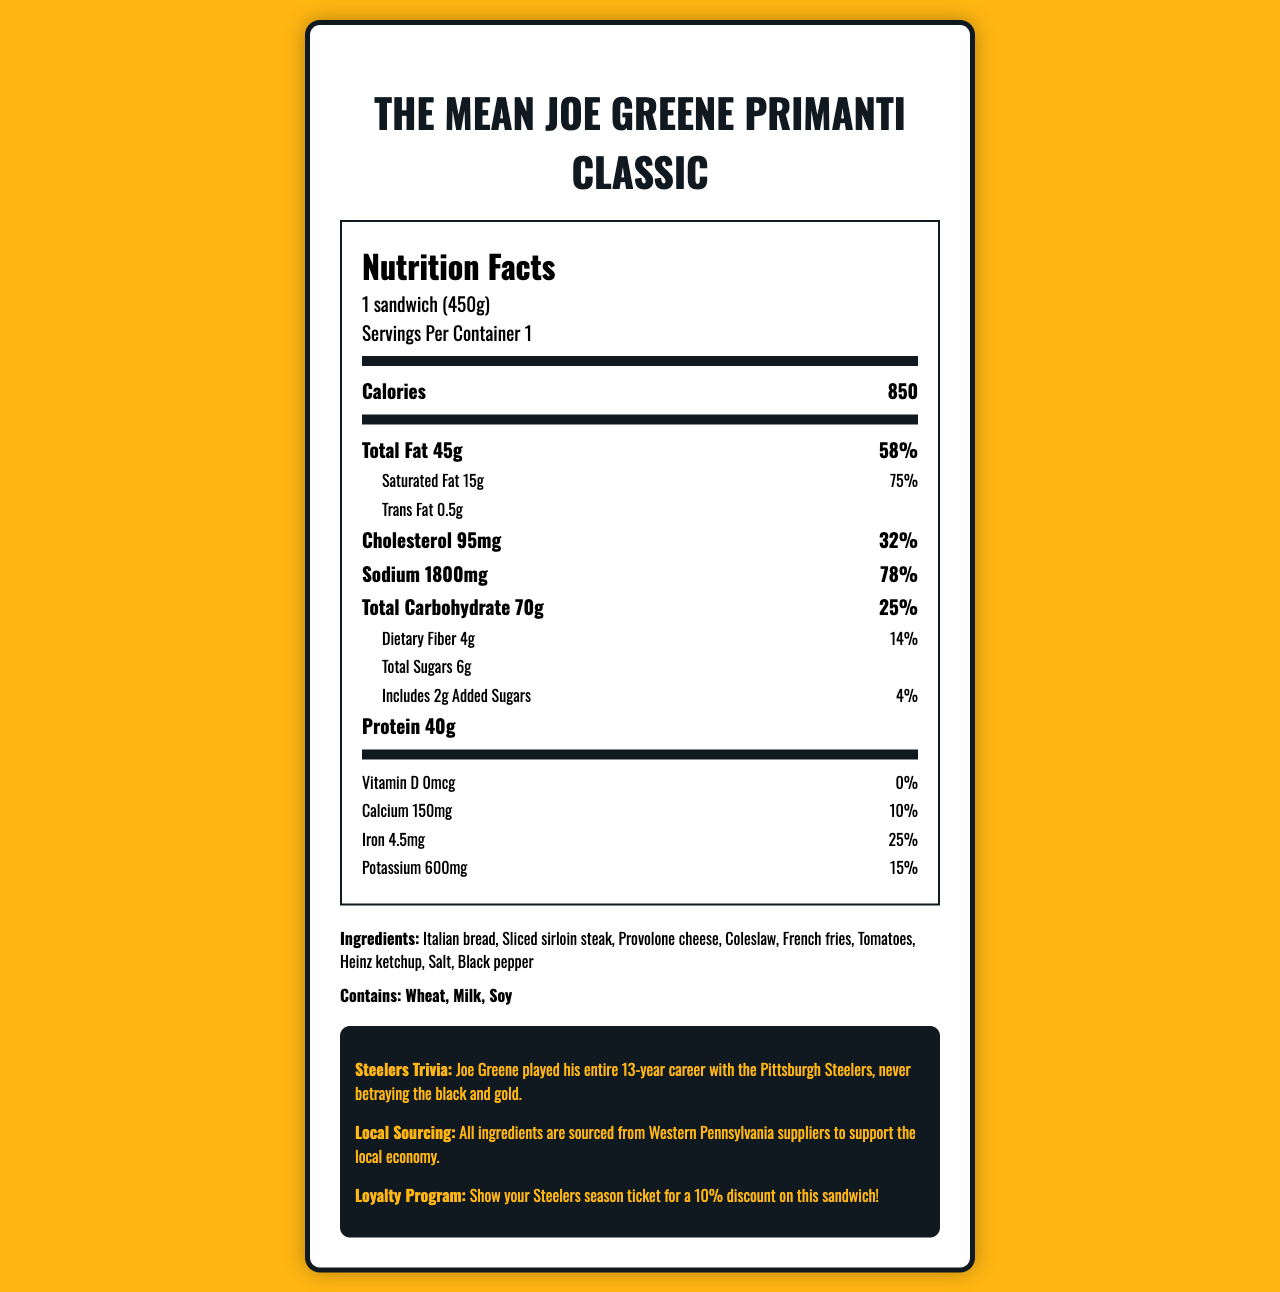what is the serving size of "The Mean Joe Greene Primanti Classic"? The serving size is stated as "1 sandwich (450g)" at the top of the nutrition label.
Answer: 1 sandwich (450g) how many calories does the sandwich contain? The calorie count is listed as "Calories 850" in the document.
Answer: 850 how much total fat is in the sandwich? The total fat content is listed in the section "Total Fat 45g" followed by its daily value percentage.
Answer: 45g how much protein does the sandwich provide? The protein content is stated as "Protein 40g" under the nutrition facts.
Answer: 40g what is the sodium content in the sandwich? The sodium content is given as "Sodium 1800mg" along with its daily value percentage.
Answer: 1800mg what is the daily value percentage of saturated fat in the sandwich? The daily value percentage for saturated fat is listed as 75% directly below the saturated fat amount.
Answer: 75% which ingredient is not present in the sandwich? A. Sliced sirloin steak B. Provolone cheese C. Lettuce D. Coleslaw The document lists the ingredients, and Lettuce is not among them.
Answer: C which of the following allergens are included in the sandwich? I. Wheat II. Milk III. Soy IV. Nuts The allergens section specifies the sandwich contains Wheat, Milk, and Soy but not Nuts.
Answer: I, II, III does the sandwich include any added sugars? The document states, "Includes 2g Added Sugars."
Answer: Yes is the sandwich suitable for someone allergic to soy? The allergens section mentions that the sandwich contains Soy.
Answer: No summarize the nutritional elements and information about "The Mean Joe Greene Primanti Classic" sandwich. The explanation describes the primary nutritional content and additional information found in the document.
Answer: The Mean Joe Greene Primanti Classic sandwich provides detailed nutritional information per serving (1 sandwich of 450g). It has 850 calories, 45g of total fat, including 15g of saturated fat and 0.5g of trans fat. It contains 95mg of cholesterol and 1800mg of sodium. The sandwich offers 70g of total carbohydrates with 4g of dietary fiber and 6g of total sugars, including 2g of added sugars. Additionally, it provides 40g of protein. Vitamins and minerals are also listed, with percentages of daily values. Ingredients and allergens are included, along with some Steelers trivia, local sourcing information, and a loyalty program. how much dietary fiber does the sandwich contain? The amount of dietary fiber is specified as "Dietary Fiber 4g" in the nutrition facts.
Answer: 4g what is the daily value percentage of iron in the sandwich? The daily value percentage of iron is listed as 25% next to the iron amount.
Answer: 25% does the sandwich contain any Heinz ketchup? Heinz ketchup is listed among the ingredients.
Answer: Yes what local sourcing information is provided about the ingredients? The document includes a note on local sourcing, mentioning the origin of the ingredients.
Answer: All ingredients are sourced from Western Pennsylvania suppliers to support the local economy. can I determine the exact amount of Vitamin C in the sandwich from this document? The document doesn't provide any information about the Vitamin C content in the sandwich.
Answer: Not enough information 